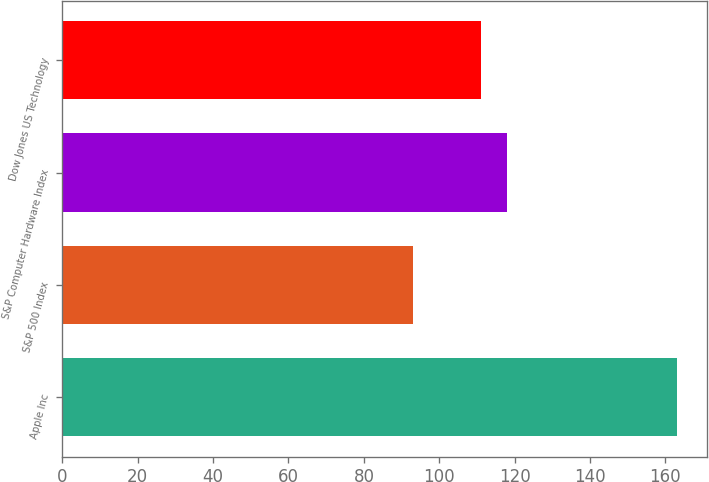Convert chart. <chart><loc_0><loc_0><loc_500><loc_500><bar_chart><fcel>Apple Inc<fcel>S&P 500 Index<fcel>S&P Computer Hardware Index<fcel>Dow Jones US Technology<nl><fcel>163<fcel>93<fcel>118<fcel>111<nl></chart> 